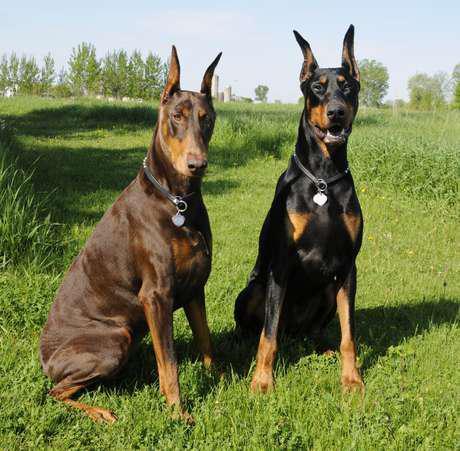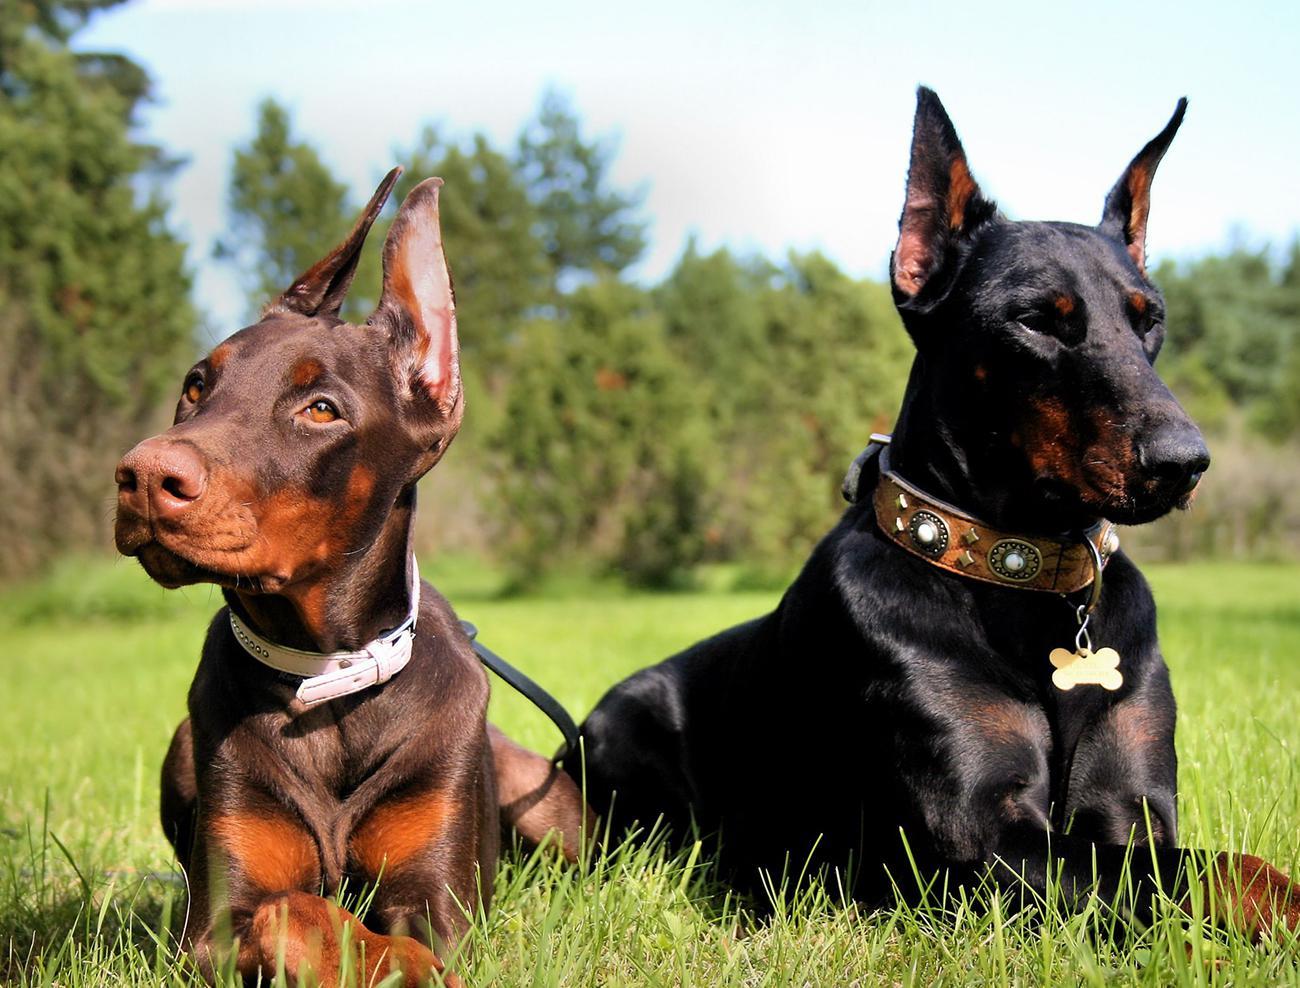The first image is the image on the left, the second image is the image on the right. Given the left and right images, does the statement "Two dogs are sitting in the grass in the image on the left, while two lie in the grass in the image on the right." hold true? Answer yes or no. Yes. 